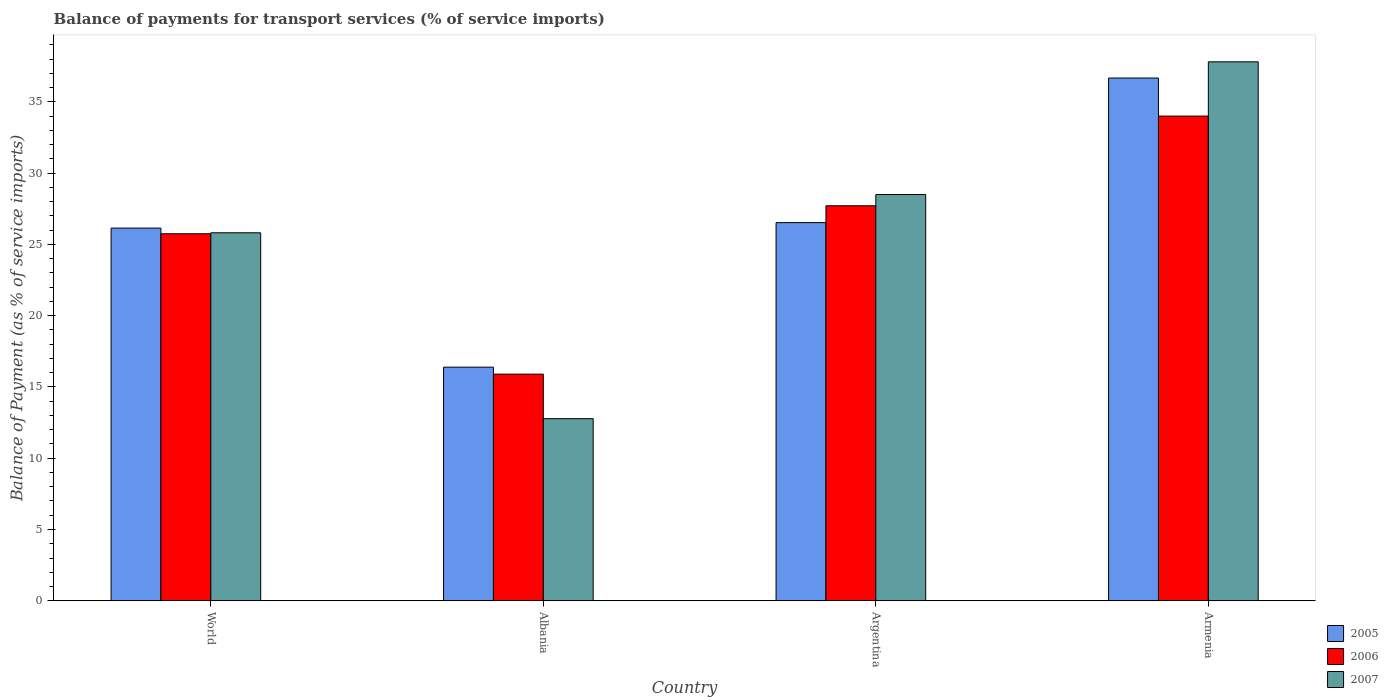Are the number of bars per tick equal to the number of legend labels?
Give a very brief answer. Yes. Are the number of bars on each tick of the X-axis equal?
Offer a terse response. Yes. How many bars are there on the 4th tick from the left?
Ensure brevity in your answer.  3. How many bars are there on the 3rd tick from the right?
Provide a short and direct response. 3. What is the label of the 3rd group of bars from the left?
Your response must be concise. Argentina. In how many cases, is the number of bars for a given country not equal to the number of legend labels?
Make the answer very short. 0. What is the balance of payments for transport services in 2006 in Armenia?
Your answer should be compact. 34. Across all countries, what is the maximum balance of payments for transport services in 2005?
Offer a terse response. 36.67. Across all countries, what is the minimum balance of payments for transport services in 2005?
Make the answer very short. 16.39. In which country was the balance of payments for transport services in 2007 maximum?
Offer a terse response. Armenia. In which country was the balance of payments for transport services in 2006 minimum?
Ensure brevity in your answer.  Albania. What is the total balance of payments for transport services in 2007 in the graph?
Offer a terse response. 104.88. What is the difference between the balance of payments for transport services in 2007 in Argentina and that in Armenia?
Keep it short and to the point. -9.31. What is the difference between the balance of payments for transport services in 2006 in Armenia and the balance of payments for transport services in 2007 in World?
Provide a short and direct response. 8.19. What is the average balance of payments for transport services in 2006 per country?
Offer a terse response. 25.84. What is the difference between the balance of payments for transport services of/in 2005 and balance of payments for transport services of/in 2006 in Albania?
Your answer should be very brief. 0.49. In how many countries, is the balance of payments for transport services in 2007 greater than 9 %?
Your answer should be compact. 4. What is the ratio of the balance of payments for transport services in 2006 in Argentina to that in Armenia?
Keep it short and to the point. 0.81. Is the difference between the balance of payments for transport services in 2005 in Albania and World greater than the difference between the balance of payments for transport services in 2006 in Albania and World?
Provide a succinct answer. Yes. What is the difference between the highest and the second highest balance of payments for transport services in 2007?
Provide a succinct answer. -2.68. What is the difference between the highest and the lowest balance of payments for transport services in 2006?
Ensure brevity in your answer.  18.1. Is the sum of the balance of payments for transport services in 2006 in Albania and Armenia greater than the maximum balance of payments for transport services in 2007 across all countries?
Provide a succinct answer. Yes. What does the 1st bar from the right in Argentina represents?
Offer a terse response. 2007. Is it the case that in every country, the sum of the balance of payments for transport services in 2006 and balance of payments for transport services in 2007 is greater than the balance of payments for transport services in 2005?
Offer a very short reply. Yes. Are all the bars in the graph horizontal?
Keep it short and to the point. No. How many countries are there in the graph?
Provide a succinct answer. 4. Are the values on the major ticks of Y-axis written in scientific E-notation?
Your answer should be very brief. No. Does the graph contain grids?
Ensure brevity in your answer.  No. Where does the legend appear in the graph?
Your answer should be very brief. Bottom right. How many legend labels are there?
Your answer should be very brief. 3. How are the legend labels stacked?
Offer a terse response. Vertical. What is the title of the graph?
Provide a succinct answer. Balance of payments for transport services (% of service imports). Does "1966" appear as one of the legend labels in the graph?
Ensure brevity in your answer.  No. What is the label or title of the X-axis?
Make the answer very short. Country. What is the label or title of the Y-axis?
Your response must be concise. Balance of Payment (as % of service imports). What is the Balance of Payment (as % of service imports) of 2005 in World?
Offer a very short reply. 26.14. What is the Balance of Payment (as % of service imports) of 2006 in World?
Provide a short and direct response. 25.74. What is the Balance of Payment (as % of service imports) of 2007 in World?
Offer a terse response. 25.81. What is the Balance of Payment (as % of service imports) of 2005 in Albania?
Keep it short and to the point. 16.39. What is the Balance of Payment (as % of service imports) of 2006 in Albania?
Your answer should be very brief. 15.9. What is the Balance of Payment (as % of service imports) in 2007 in Albania?
Keep it short and to the point. 12.77. What is the Balance of Payment (as % of service imports) in 2005 in Argentina?
Offer a terse response. 26.52. What is the Balance of Payment (as % of service imports) in 2006 in Argentina?
Your answer should be very brief. 27.71. What is the Balance of Payment (as % of service imports) of 2007 in Argentina?
Provide a short and direct response. 28.49. What is the Balance of Payment (as % of service imports) of 2005 in Armenia?
Provide a short and direct response. 36.67. What is the Balance of Payment (as % of service imports) of 2006 in Armenia?
Keep it short and to the point. 34. What is the Balance of Payment (as % of service imports) in 2007 in Armenia?
Provide a succinct answer. 37.8. Across all countries, what is the maximum Balance of Payment (as % of service imports) of 2005?
Provide a succinct answer. 36.67. Across all countries, what is the maximum Balance of Payment (as % of service imports) of 2006?
Your answer should be very brief. 34. Across all countries, what is the maximum Balance of Payment (as % of service imports) in 2007?
Offer a terse response. 37.8. Across all countries, what is the minimum Balance of Payment (as % of service imports) in 2005?
Make the answer very short. 16.39. Across all countries, what is the minimum Balance of Payment (as % of service imports) of 2006?
Your answer should be very brief. 15.9. Across all countries, what is the minimum Balance of Payment (as % of service imports) in 2007?
Offer a very short reply. 12.77. What is the total Balance of Payment (as % of service imports) in 2005 in the graph?
Provide a succinct answer. 105.72. What is the total Balance of Payment (as % of service imports) of 2006 in the graph?
Your response must be concise. 103.34. What is the total Balance of Payment (as % of service imports) of 2007 in the graph?
Your answer should be very brief. 104.88. What is the difference between the Balance of Payment (as % of service imports) of 2005 in World and that in Albania?
Your response must be concise. 9.75. What is the difference between the Balance of Payment (as % of service imports) in 2006 in World and that in Albania?
Make the answer very short. 9.85. What is the difference between the Balance of Payment (as % of service imports) of 2007 in World and that in Albania?
Make the answer very short. 13.04. What is the difference between the Balance of Payment (as % of service imports) in 2005 in World and that in Argentina?
Make the answer very short. -0.38. What is the difference between the Balance of Payment (as % of service imports) of 2006 in World and that in Argentina?
Your answer should be compact. -1.96. What is the difference between the Balance of Payment (as % of service imports) in 2007 in World and that in Argentina?
Give a very brief answer. -2.68. What is the difference between the Balance of Payment (as % of service imports) in 2005 in World and that in Armenia?
Offer a very short reply. -10.53. What is the difference between the Balance of Payment (as % of service imports) of 2006 in World and that in Armenia?
Give a very brief answer. -8.25. What is the difference between the Balance of Payment (as % of service imports) of 2007 in World and that in Armenia?
Keep it short and to the point. -11.99. What is the difference between the Balance of Payment (as % of service imports) in 2005 in Albania and that in Argentina?
Provide a short and direct response. -10.14. What is the difference between the Balance of Payment (as % of service imports) in 2006 in Albania and that in Argentina?
Give a very brief answer. -11.81. What is the difference between the Balance of Payment (as % of service imports) of 2007 in Albania and that in Argentina?
Ensure brevity in your answer.  -15.72. What is the difference between the Balance of Payment (as % of service imports) of 2005 in Albania and that in Armenia?
Your response must be concise. -20.28. What is the difference between the Balance of Payment (as % of service imports) of 2006 in Albania and that in Armenia?
Your answer should be very brief. -18.1. What is the difference between the Balance of Payment (as % of service imports) of 2007 in Albania and that in Armenia?
Your response must be concise. -25.03. What is the difference between the Balance of Payment (as % of service imports) of 2005 in Argentina and that in Armenia?
Your answer should be compact. -10.14. What is the difference between the Balance of Payment (as % of service imports) of 2006 in Argentina and that in Armenia?
Keep it short and to the point. -6.29. What is the difference between the Balance of Payment (as % of service imports) of 2007 in Argentina and that in Armenia?
Provide a short and direct response. -9.31. What is the difference between the Balance of Payment (as % of service imports) in 2005 in World and the Balance of Payment (as % of service imports) in 2006 in Albania?
Give a very brief answer. 10.24. What is the difference between the Balance of Payment (as % of service imports) of 2005 in World and the Balance of Payment (as % of service imports) of 2007 in Albania?
Make the answer very short. 13.37. What is the difference between the Balance of Payment (as % of service imports) in 2006 in World and the Balance of Payment (as % of service imports) in 2007 in Albania?
Your answer should be very brief. 12.97. What is the difference between the Balance of Payment (as % of service imports) in 2005 in World and the Balance of Payment (as % of service imports) in 2006 in Argentina?
Make the answer very short. -1.57. What is the difference between the Balance of Payment (as % of service imports) in 2005 in World and the Balance of Payment (as % of service imports) in 2007 in Argentina?
Your answer should be compact. -2.35. What is the difference between the Balance of Payment (as % of service imports) of 2006 in World and the Balance of Payment (as % of service imports) of 2007 in Argentina?
Give a very brief answer. -2.75. What is the difference between the Balance of Payment (as % of service imports) in 2005 in World and the Balance of Payment (as % of service imports) in 2006 in Armenia?
Your answer should be very brief. -7.86. What is the difference between the Balance of Payment (as % of service imports) in 2005 in World and the Balance of Payment (as % of service imports) in 2007 in Armenia?
Make the answer very short. -11.66. What is the difference between the Balance of Payment (as % of service imports) in 2006 in World and the Balance of Payment (as % of service imports) in 2007 in Armenia?
Keep it short and to the point. -12.06. What is the difference between the Balance of Payment (as % of service imports) of 2005 in Albania and the Balance of Payment (as % of service imports) of 2006 in Argentina?
Make the answer very short. -11.32. What is the difference between the Balance of Payment (as % of service imports) in 2005 in Albania and the Balance of Payment (as % of service imports) in 2007 in Argentina?
Ensure brevity in your answer.  -12.11. What is the difference between the Balance of Payment (as % of service imports) of 2006 in Albania and the Balance of Payment (as % of service imports) of 2007 in Argentina?
Your response must be concise. -12.6. What is the difference between the Balance of Payment (as % of service imports) in 2005 in Albania and the Balance of Payment (as % of service imports) in 2006 in Armenia?
Your answer should be very brief. -17.61. What is the difference between the Balance of Payment (as % of service imports) in 2005 in Albania and the Balance of Payment (as % of service imports) in 2007 in Armenia?
Your answer should be very brief. -21.42. What is the difference between the Balance of Payment (as % of service imports) of 2006 in Albania and the Balance of Payment (as % of service imports) of 2007 in Armenia?
Offer a terse response. -21.91. What is the difference between the Balance of Payment (as % of service imports) in 2005 in Argentina and the Balance of Payment (as % of service imports) in 2006 in Armenia?
Provide a succinct answer. -7.47. What is the difference between the Balance of Payment (as % of service imports) of 2005 in Argentina and the Balance of Payment (as % of service imports) of 2007 in Armenia?
Keep it short and to the point. -11.28. What is the difference between the Balance of Payment (as % of service imports) in 2006 in Argentina and the Balance of Payment (as % of service imports) in 2007 in Armenia?
Your response must be concise. -10.1. What is the average Balance of Payment (as % of service imports) in 2005 per country?
Offer a very short reply. 26.43. What is the average Balance of Payment (as % of service imports) of 2006 per country?
Offer a terse response. 25.84. What is the average Balance of Payment (as % of service imports) in 2007 per country?
Your answer should be very brief. 26.22. What is the difference between the Balance of Payment (as % of service imports) in 2005 and Balance of Payment (as % of service imports) in 2006 in World?
Your answer should be very brief. 0.4. What is the difference between the Balance of Payment (as % of service imports) of 2005 and Balance of Payment (as % of service imports) of 2007 in World?
Ensure brevity in your answer.  0.33. What is the difference between the Balance of Payment (as % of service imports) of 2006 and Balance of Payment (as % of service imports) of 2007 in World?
Your answer should be compact. -0.07. What is the difference between the Balance of Payment (as % of service imports) in 2005 and Balance of Payment (as % of service imports) in 2006 in Albania?
Offer a terse response. 0.49. What is the difference between the Balance of Payment (as % of service imports) in 2005 and Balance of Payment (as % of service imports) in 2007 in Albania?
Your response must be concise. 3.61. What is the difference between the Balance of Payment (as % of service imports) of 2006 and Balance of Payment (as % of service imports) of 2007 in Albania?
Ensure brevity in your answer.  3.12. What is the difference between the Balance of Payment (as % of service imports) of 2005 and Balance of Payment (as % of service imports) of 2006 in Argentina?
Offer a very short reply. -1.18. What is the difference between the Balance of Payment (as % of service imports) of 2005 and Balance of Payment (as % of service imports) of 2007 in Argentina?
Give a very brief answer. -1.97. What is the difference between the Balance of Payment (as % of service imports) in 2006 and Balance of Payment (as % of service imports) in 2007 in Argentina?
Ensure brevity in your answer.  -0.79. What is the difference between the Balance of Payment (as % of service imports) in 2005 and Balance of Payment (as % of service imports) in 2006 in Armenia?
Your answer should be compact. 2.67. What is the difference between the Balance of Payment (as % of service imports) in 2005 and Balance of Payment (as % of service imports) in 2007 in Armenia?
Keep it short and to the point. -1.14. What is the difference between the Balance of Payment (as % of service imports) of 2006 and Balance of Payment (as % of service imports) of 2007 in Armenia?
Your response must be concise. -3.8. What is the ratio of the Balance of Payment (as % of service imports) of 2005 in World to that in Albania?
Your answer should be compact. 1.6. What is the ratio of the Balance of Payment (as % of service imports) in 2006 in World to that in Albania?
Your answer should be compact. 1.62. What is the ratio of the Balance of Payment (as % of service imports) in 2007 in World to that in Albania?
Give a very brief answer. 2.02. What is the ratio of the Balance of Payment (as % of service imports) of 2005 in World to that in Argentina?
Ensure brevity in your answer.  0.99. What is the ratio of the Balance of Payment (as % of service imports) of 2006 in World to that in Argentina?
Offer a terse response. 0.93. What is the ratio of the Balance of Payment (as % of service imports) of 2007 in World to that in Argentina?
Provide a succinct answer. 0.91. What is the ratio of the Balance of Payment (as % of service imports) in 2005 in World to that in Armenia?
Ensure brevity in your answer.  0.71. What is the ratio of the Balance of Payment (as % of service imports) of 2006 in World to that in Armenia?
Your response must be concise. 0.76. What is the ratio of the Balance of Payment (as % of service imports) of 2007 in World to that in Armenia?
Your response must be concise. 0.68. What is the ratio of the Balance of Payment (as % of service imports) in 2005 in Albania to that in Argentina?
Keep it short and to the point. 0.62. What is the ratio of the Balance of Payment (as % of service imports) of 2006 in Albania to that in Argentina?
Your answer should be very brief. 0.57. What is the ratio of the Balance of Payment (as % of service imports) of 2007 in Albania to that in Argentina?
Ensure brevity in your answer.  0.45. What is the ratio of the Balance of Payment (as % of service imports) of 2005 in Albania to that in Armenia?
Your answer should be compact. 0.45. What is the ratio of the Balance of Payment (as % of service imports) in 2006 in Albania to that in Armenia?
Make the answer very short. 0.47. What is the ratio of the Balance of Payment (as % of service imports) of 2007 in Albania to that in Armenia?
Ensure brevity in your answer.  0.34. What is the ratio of the Balance of Payment (as % of service imports) in 2005 in Argentina to that in Armenia?
Make the answer very short. 0.72. What is the ratio of the Balance of Payment (as % of service imports) in 2006 in Argentina to that in Armenia?
Offer a very short reply. 0.81. What is the ratio of the Balance of Payment (as % of service imports) in 2007 in Argentina to that in Armenia?
Provide a short and direct response. 0.75. What is the difference between the highest and the second highest Balance of Payment (as % of service imports) in 2005?
Your answer should be compact. 10.14. What is the difference between the highest and the second highest Balance of Payment (as % of service imports) of 2006?
Provide a short and direct response. 6.29. What is the difference between the highest and the second highest Balance of Payment (as % of service imports) of 2007?
Your response must be concise. 9.31. What is the difference between the highest and the lowest Balance of Payment (as % of service imports) in 2005?
Offer a terse response. 20.28. What is the difference between the highest and the lowest Balance of Payment (as % of service imports) of 2006?
Keep it short and to the point. 18.1. What is the difference between the highest and the lowest Balance of Payment (as % of service imports) of 2007?
Your answer should be very brief. 25.03. 